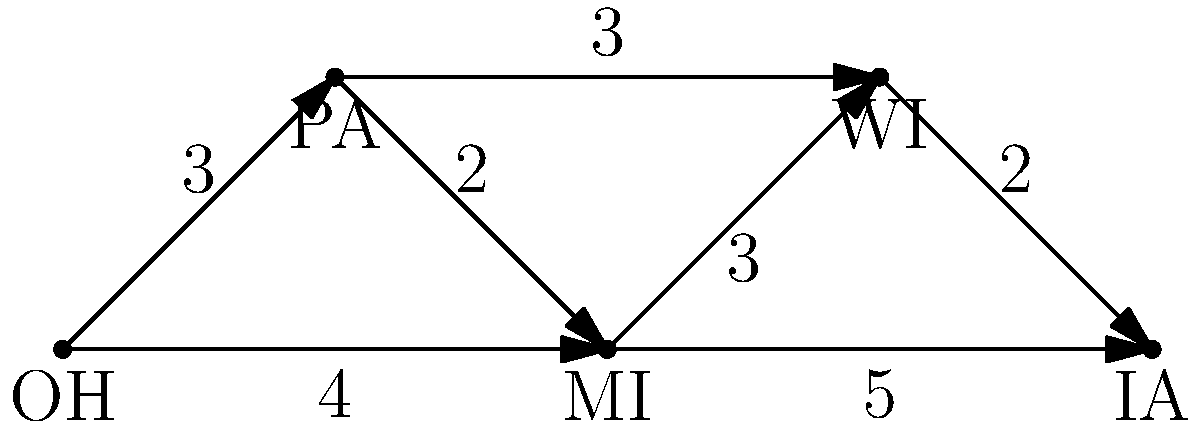As a political strategist planning a campaign tour through key swing states, you need to determine the shortest path that visits all five states (OH, PA, MI, WI, and IA) exactly once, starting from Ohio (OH) and ending in Iowa (IA). The numbers on the edges represent travel times in hours. What is the minimum total travel time for this optimal campaign route? To solve this problem, we need to find the shortest Hamiltonian path from OH to IA in the given graph. Here's a step-by-step approach:

1) First, list all possible paths from OH to IA that visit each state exactly once:
   
   a) OH -> PA -> MI -> WI -> IA
   b) OH -> PA -> WI -> MI -> IA
   c) OH -> MI -> PA -> WI -> IA
   d) OH -> MI -> WI -> PA -> IA

2) Calculate the total travel time for each path:

   a) OH -> PA -> MI -> WI -> IA
      Time = 3 + 2 + 3 + 2 = 10 hours
   
   b) OH -> PA -> WI -> MI -> IA
      Time = 3 + 3 + 3 + 5 = 14 hours
   
   c) OH -> MI -> PA -> WI -> IA
      Time = 4 + 2 + 3 + 2 = 11 hours
   
   d) OH -> MI -> WI -> PA -> IA
      This path is not possible as there's no direct connection between PA and IA.

3) Compare the total times:
   Path (a): 10 hours
   Path (b): 14 hours
   Path (c): 11 hours
   Path (d): Not possible

Therefore, the shortest path is (a) OH -> PA -> MI -> WI -> IA, with a total travel time of 10 hours.
Answer: 10 hours 